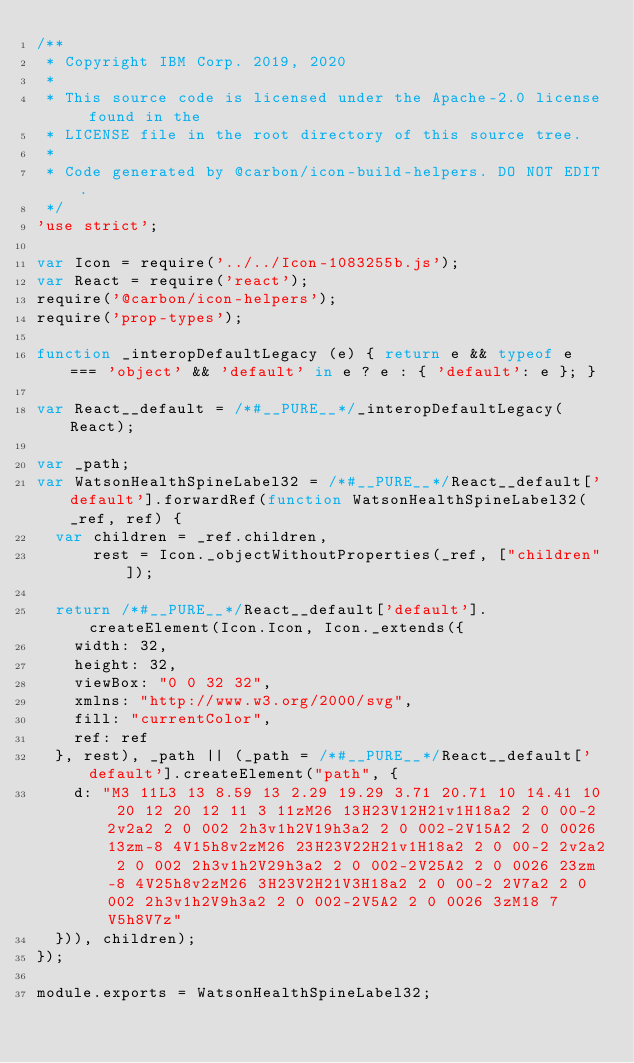Convert code to text. <code><loc_0><loc_0><loc_500><loc_500><_JavaScript_>/**
 * Copyright IBM Corp. 2019, 2020
 *
 * This source code is licensed under the Apache-2.0 license found in the
 * LICENSE file in the root directory of this source tree.
 *
 * Code generated by @carbon/icon-build-helpers. DO NOT EDIT.
 */
'use strict';

var Icon = require('../../Icon-1083255b.js');
var React = require('react');
require('@carbon/icon-helpers');
require('prop-types');

function _interopDefaultLegacy (e) { return e && typeof e === 'object' && 'default' in e ? e : { 'default': e }; }

var React__default = /*#__PURE__*/_interopDefaultLegacy(React);

var _path;
var WatsonHealthSpineLabel32 = /*#__PURE__*/React__default['default'].forwardRef(function WatsonHealthSpineLabel32(_ref, ref) {
  var children = _ref.children,
      rest = Icon._objectWithoutProperties(_ref, ["children"]);

  return /*#__PURE__*/React__default['default'].createElement(Icon.Icon, Icon._extends({
    width: 32,
    height: 32,
    viewBox: "0 0 32 32",
    xmlns: "http://www.w3.org/2000/svg",
    fill: "currentColor",
    ref: ref
  }, rest), _path || (_path = /*#__PURE__*/React__default['default'].createElement("path", {
    d: "M3 11L3 13 8.59 13 2.29 19.29 3.71 20.71 10 14.41 10 20 12 20 12 11 3 11zM26 13H23V12H21v1H18a2 2 0 00-2 2v2a2 2 0 002 2h3v1h2V19h3a2 2 0 002-2V15A2 2 0 0026 13zm-8 4V15h8v2zM26 23H23V22H21v1H18a2 2 0 00-2 2v2a2 2 0 002 2h3v1h2V29h3a2 2 0 002-2V25A2 2 0 0026 23zm-8 4V25h8v2zM26 3H23V2H21V3H18a2 2 0 00-2 2V7a2 2 0 002 2h3v1h2V9h3a2 2 0 002-2V5A2 2 0 0026 3zM18 7V5h8V7z"
  })), children);
});

module.exports = WatsonHealthSpineLabel32;
</code> 